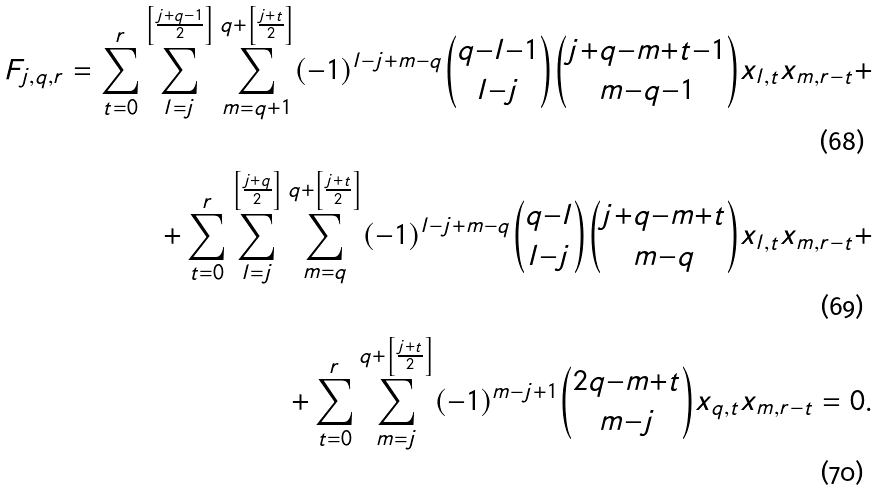<formula> <loc_0><loc_0><loc_500><loc_500>F _ { j , q , r } = \sum _ { t { = } 0 } ^ { r } \sum _ { l { = } j } ^ { \left [ \frac { j { + } q { - } 1 } { 2 } \right ] } \sum _ { m { = } q { + } 1 } ^ { q { + } \left [ \frac { j { + } t } { 2 } \right ] } ( { - } 1 ) ^ { l { - } j { + } m { - } q } \binom { q { - } l { - } 1 } { l { - } j } \binom { j { + } q { - } m { + } t { - } 1 } { m { - } q { - } 1 } x _ { l , t } x _ { m , r { - } t } + \\ + \sum _ { t { = } 0 } ^ { r } \sum _ { l { = } j } ^ { \left [ \frac { j { + } q } { 2 } \right ] } \sum _ { m { = } q } ^ { q { + } \left [ \frac { j { + } t } { 2 } \right ] } ( { - } 1 ) ^ { l { - } j { + } m { - } q } \binom { q { - } l } { l { - } j } \binom { j { + } q { - } m { + } t } { m { - } q } x _ { l , t } x _ { m , r { - } t } + \\ + \sum _ { t { = } 0 } ^ { r } \sum _ { m { = } j } ^ { q { + } \left [ \frac { j { + } t } { 2 } \right ] } ( { - } 1 ) ^ { m { - } j { + } 1 } \binom { 2 q { - } m { + } t } { m { - } j } x _ { q , t } x _ { m , r { - } t } = 0 .</formula> 